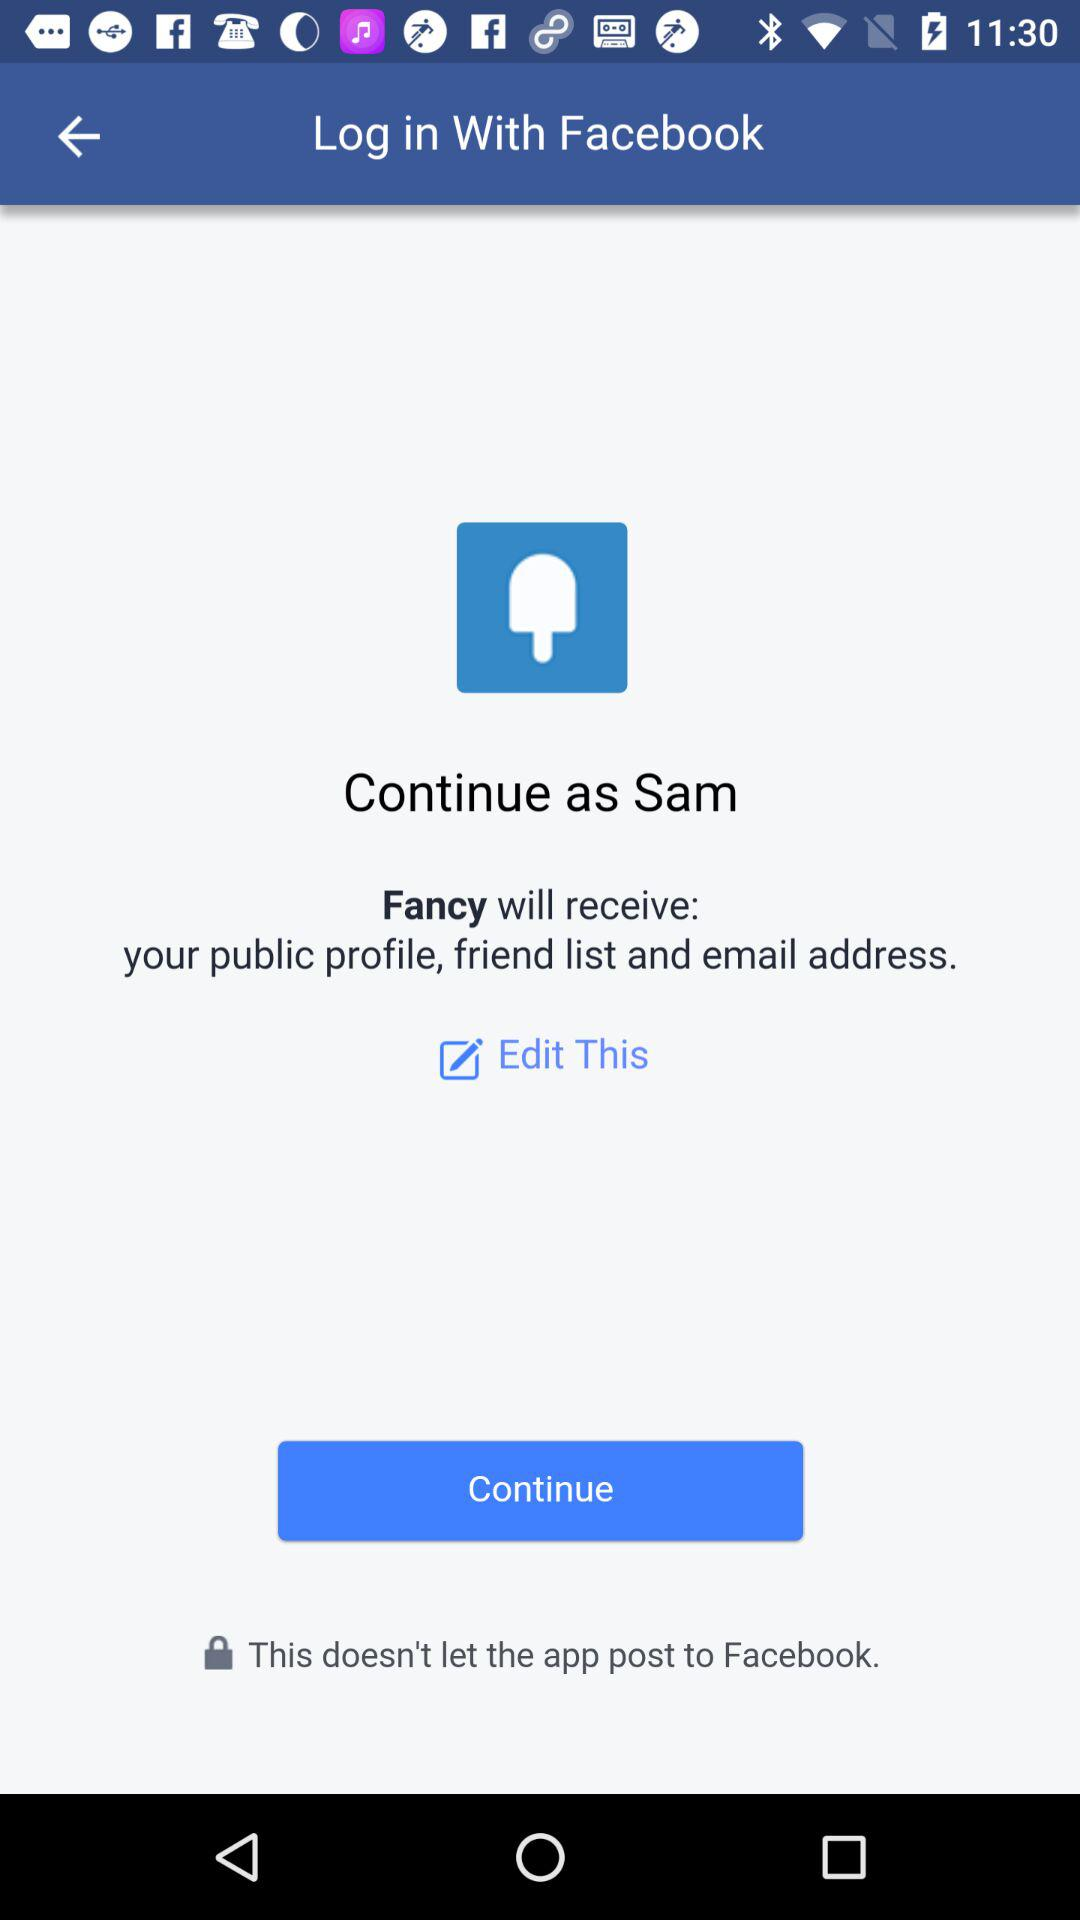What is the name of the user? The name of the user is Sam. 